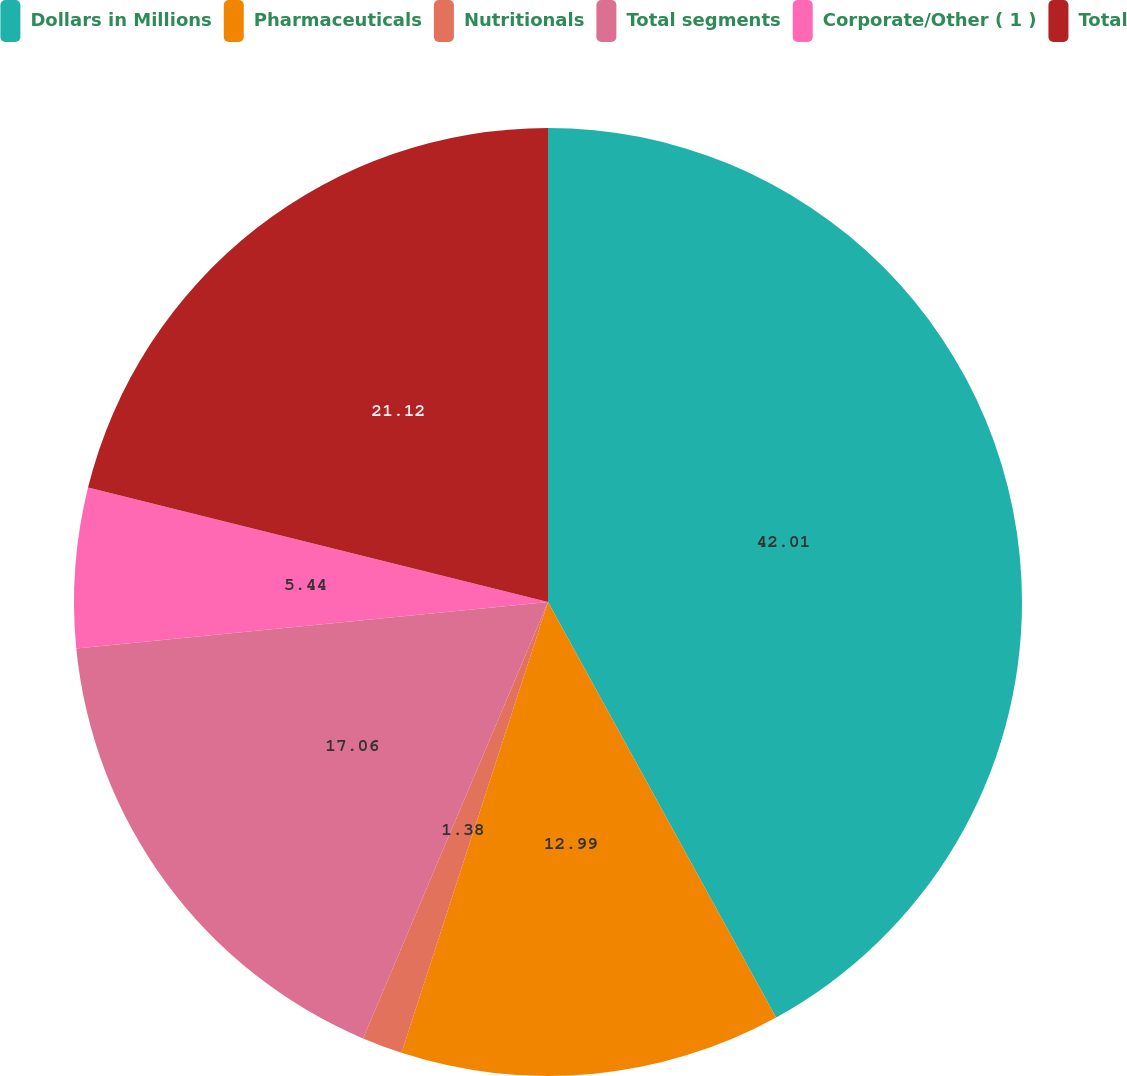Convert chart to OTSL. <chart><loc_0><loc_0><loc_500><loc_500><pie_chart><fcel>Dollars in Millions<fcel>Pharmaceuticals<fcel>Nutritionals<fcel>Total segments<fcel>Corporate/Other ( 1 )<fcel>Total<nl><fcel>42.01%<fcel>12.99%<fcel>1.38%<fcel>17.06%<fcel>5.44%<fcel>21.12%<nl></chart> 